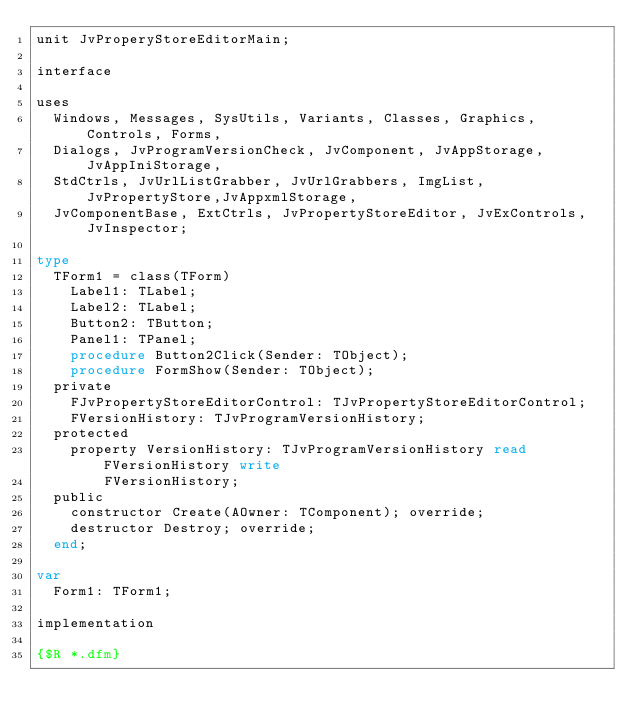<code> <loc_0><loc_0><loc_500><loc_500><_Pascal_>unit JvProperyStoreEditorMain;

interface

uses
  Windows, Messages, SysUtils, Variants, Classes, Graphics, Controls, Forms,
  Dialogs, JvProgramVersionCheck, JvComponent, JvAppStorage, JvAppIniStorage,
  StdCtrls, JvUrlListGrabber, JvUrlGrabbers, ImgList, JvPropertyStore,JvAppxmlStorage,
  JvComponentBase, ExtCtrls, JvPropertyStoreEditor, JvExControls, JvInspector;

type
  TForm1 = class(TForm)
    Label1: TLabel;
    Label2: TLabel;
    Button2: TButton;
    Panel1: TPanel;
    procedure Button2Click(Sender: TObject);
    procedure FormShow(Sender: TObject);
  private
    FJvPropertyStoreEditorControl: TJvPropertyStoreEditorControl;
    FVersionHistory: TJvProgramVersionHistory;
  protected
    property VersionHistory: TJvProgramVersionHistory read FVersionHistory write
        FVersionHistory;
  public
    constructor Create(AOwner: TComponent); override;
    destructor Destroy; override;
  end;

var
  Form1: TForm1;

implementation

{$R *.dfm}
</code> 